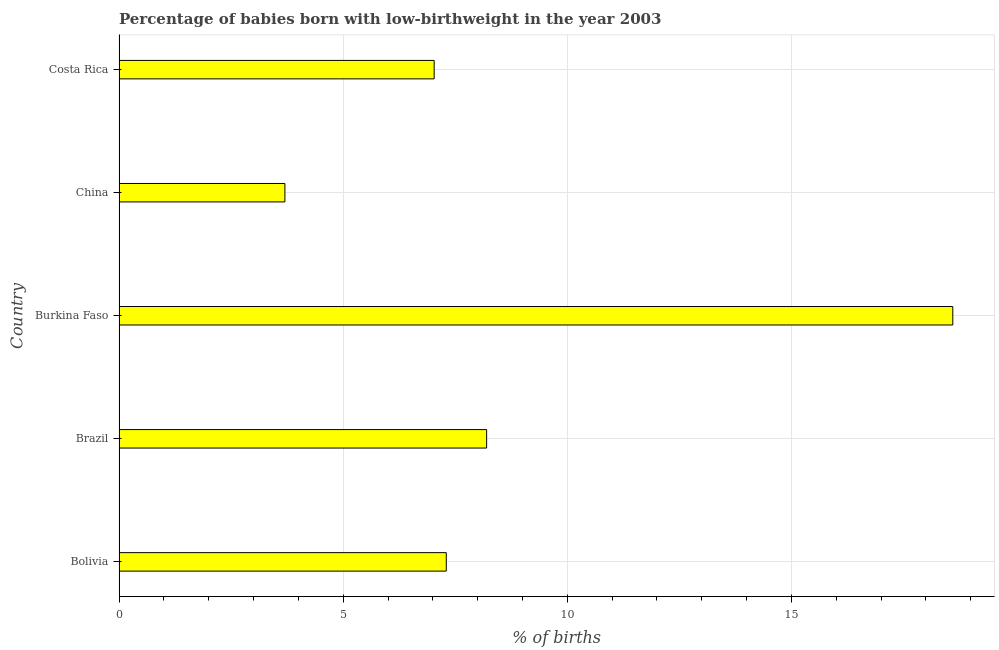Does the graph contain any zero values?
Give a very brief answer. No. What is the title of the graph?
Provide a succinct answer. Percentage of babies born with low-birthweight in the year 2003. What is the label or title of the X-axis?
Provide a succinct answer. % of births. Across all countries, what is the maximum percentage of babies who were born with low-birthweight?
Your answer should be very brief. 18.6. Across all countries, what is the minimum percentage of babies who were born with low-birthweight?
Offer a terse response. 3.7. In which country was the percentage of babies who were born with low-birthweight maximum?
Provide a succinct answer. Burkina Faso. In which country was the percentage of babies who were born with low-birthweight minimum?
Make the answer very short. China. What is the sum of the percentage of babies who were born with low-birthweight?
Your answer should be compact. 44.83. What is the average percentage of babies who were born with low-birthweight per country?
Provide a succinct answer. 8.97. What is the median percentage of babies who were born with low-birthweight?
Provide a succinct answer. 7.3. What is the ratio of the percentage of babies who were born with low-birthweight in Brazil to that in China?
Provide a succinct answer. 2.22. What is the difference between the highest and the second highest percentage of babies who were born with low-birthweight?
Your answer should be compact. 10.4. What is the difference between the highest and the lowest percentage of babies who were born with low-birthweight?
Your answer should be very brief. 14.9. In how many countries, is the percentage of babies who were born with low-birthweight greater than the average percentage of babies who were born with low-birthweight taken over all countries?
Ensure brevity in your answer.  1. How many countries are there in the graph?
Ensure brevity in your answer.  5. Are the values on the major ticks of X-axis written in scientific E-notation?
Provide a short and direct response. No. What is the % of births in Bolivia?
Make the answer very short. 7.3. What is the % of births in Brazil?
Your response must be concise. 8.2. What is the % of births in Costa Rica?
Offer a very short reply. 7.03. What is the difference between the % of births in Bolivia and Brazil?
Ensure brevity in your answer.  -0.9. What is the difference between the % of births in Bolivia and Burkina Faso?
Give a very brief answer. -11.3. What is the difference between the % of births in Bolivia and Costa Rica?
Your answer should be compact. 0.27. What is the difference between the % of births in Brazil and Burkina Faso?
Provide a succinct answer. -10.4. What is the difference between the % of births in Brazil and Costa Rica?
Offer a terse response. 1.17. What is the difference between the % of births in Burkina Faso and Costa Rica?
Give a very brief answer. 11.57. What is the difference between the % of births in China and Costa Rica?
Make the answer very short. -3.33. What is the ratio of the % of births in Bolivia to that in Brazil?
Give a very brief answer. 0.89. What is the ratio of the % of births in Bolivia to that in Burkina Faso?
Give a very brief answer. 0.39. What is the ratio of the % of births in Bolivia to that in China?
Your response must be concise. 1.97. What is the ratio of the % of births in Bolivia to that in Costa Rica?
Your response must be concise. 1.04. What is the ratio of the % of births in Brazil to that in Burkina Faso?
Keep it short and to the point. 0.44. What is the ratio of the % of births in Brazil to that in China?
Ensure brevity in your answer.  2.22. What is the ratio of the % of births in Brazil to that in Costa Rica?
Ensure brevity in your answer.  1.17. What is the ratio of the % of births in Burkina Faso to that in China?
Offer a terse response. 5.03. What is the ratio of the % of births in Burkina Faso to that in Costa Rica?
Offer a terse response. 2.65. What is the ratio of the % of births in China to that in Costa Rica?
Your response must be concise. 0.53. 